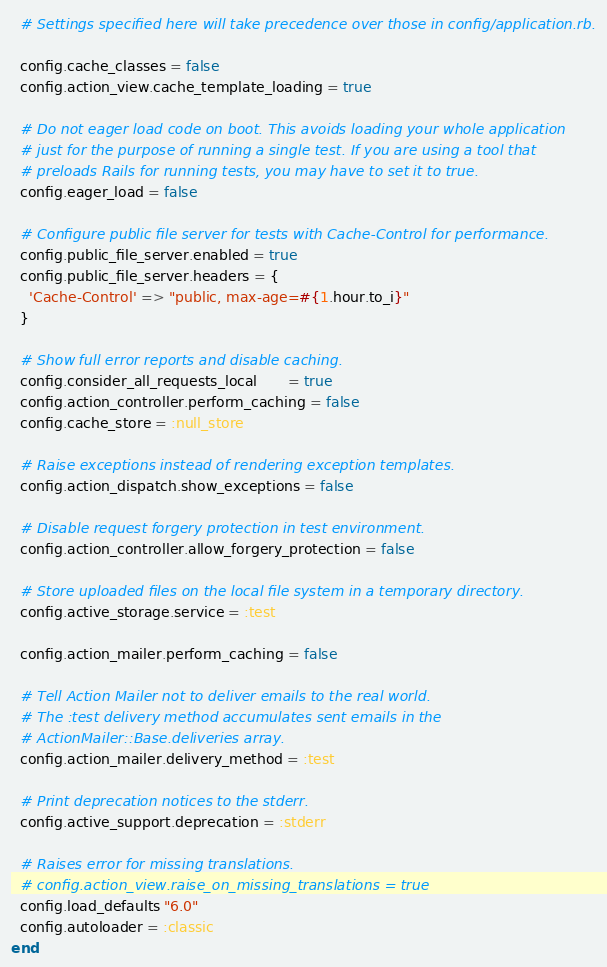<code> <loc_0><loc_0><loc_500><loc_500><_Ruby_>  # Settings specified here will take precedence over those in config/application.rb.

  config.cache_classes = false
  config.action_view.cache_template_loading = true

  # Do not eager load code on boot. This avoids loading your whole application
  # just for the purpose of running a single test. If you are using a tool that
  # preloads Rails for running tests, you may have to set it to true.
  config.eager_load = false

  # Configure public file server for tests with Cache-Control for performance.
  config.public_file_server.enabled = true
  config.public_file_server.headers = {
    'Cache-Control' => "public, max-age=#{1.hour.to_i}"
  }

  # Show full error reports and disable caching.
  config.consider_all_requests_local       = true
  config.action_controller.perform_caching = false
  config.cache_store = :null_store

  # Raise exceptions instead of rendering exception templates.
  config.action_dispatch.show_exceptions = false

  # Disable request forgery protection in test environment.
  config.action_controller.allow_forgery_protection = false

  # Store uploaded files on the local file system in a temporary directory.
  config.active_storage.service = :test

  config.action_mailer.perform_caching = false

  # Tell Action Mailer not to deliver emails to the real world.
  # The :test delivery method accumulates sent emails in the
  # ActionMailer::Base.deliveries array.
  config.action_mailer.delivery_method = :test

  # Print deprecation notices to the stderr.
  config.active_support.deprecation = :stderr

  # Raises error for missing translations.
  # config.action_view.raise_on_missing_translations = true
  config.load_defaults "6.0"
  config.autoloader = :classic
end
</code> 